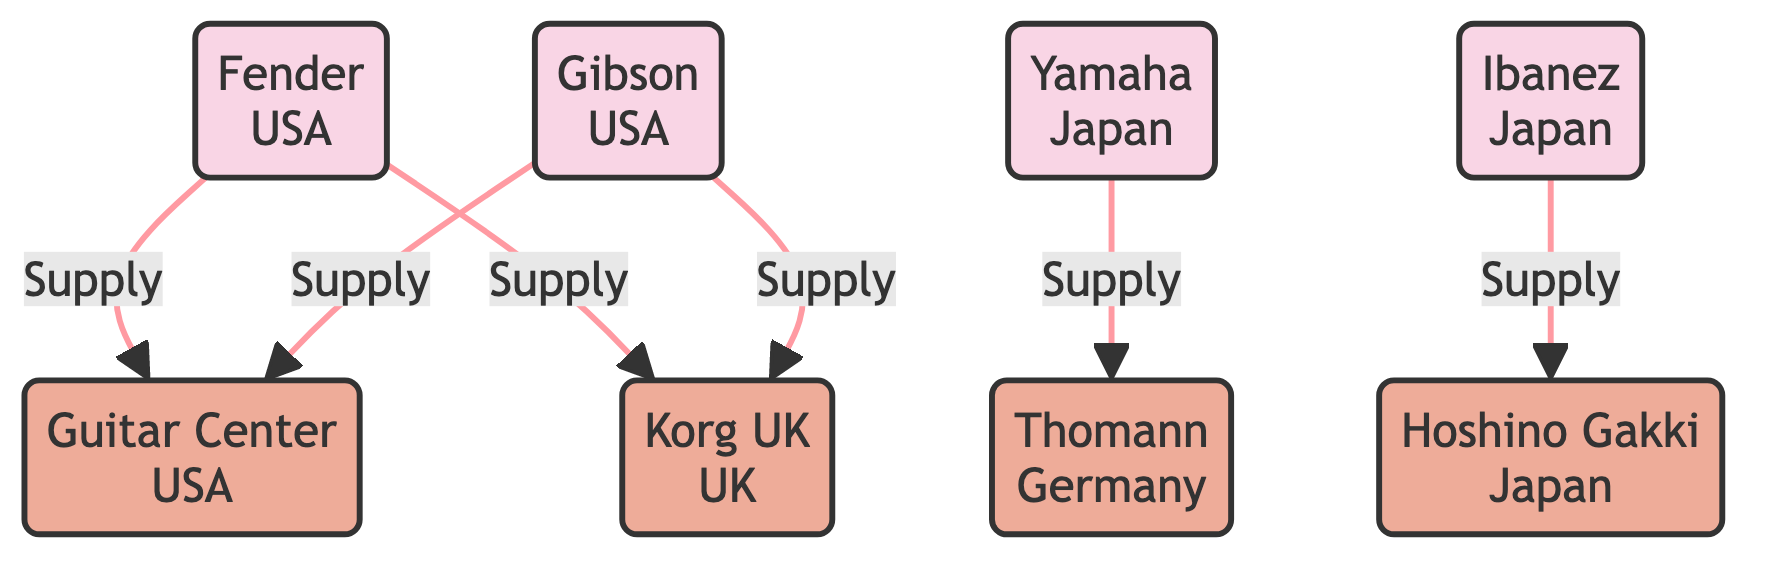What are the key models of Fender? The node labeled 'Fender' specifies that its key models are the 'Stratocaster' and 'Telecaster'. This information is represented directly in the node's description.
Answer: Stratocaster, Telecaster Which brands are supplied to Guitar Center? The edges coming from the brands to 'Guitar Center' indicate supply lines. Both 'Fender' and 'Gibson' have direct supply connections to 'Guitar Center'. Thus, these two brands are supplied to this dealer.
Answer: Fender, Gibson How many dealers are shown in the diagram? The diagram highlights four distinct dealers. They are 'Guitar Center', 'Thomann', 'Korg UK', and 'Hoshino Gakki'. By counting these individual dealer nodes, the total can be established.
Answer: 4 What is the origin of Yamaha? The 'Yamaha' node indicates that its origin is 'Japan', a detail specified within the node's information.
Answer: Japan Which dealer supplies Ibanez? The edge from 'Ibanez' to the 'Hoshino Gakki' node denotes that Hoshino Gakki is the dealer receiving supply from Ibanez. This relationship confirms the answer.
Answer: Hoshino Gakki How many brands are connected to Korg UK? There are two edges leading to 'Korg UK', one from 'Fender' and the other from 'Gibson'. Counting these connections reveals there are two brands linked to this dealer.
Answer: 2 What types of nodes are represented in the diagram? The diagram includes two types of nodes: 'Brand' and 'Dealer'. The classifications provided in the node style indicate which nodes fall under each category.
Answer: Brand, Dealer Which brand is connected to the most dealers? By examining the connections, 'Fender' has supply lines to both 'Guitar Center' and 'Korg UK', making it connected to two dealers, more than any other brand.
Answer: Fender 